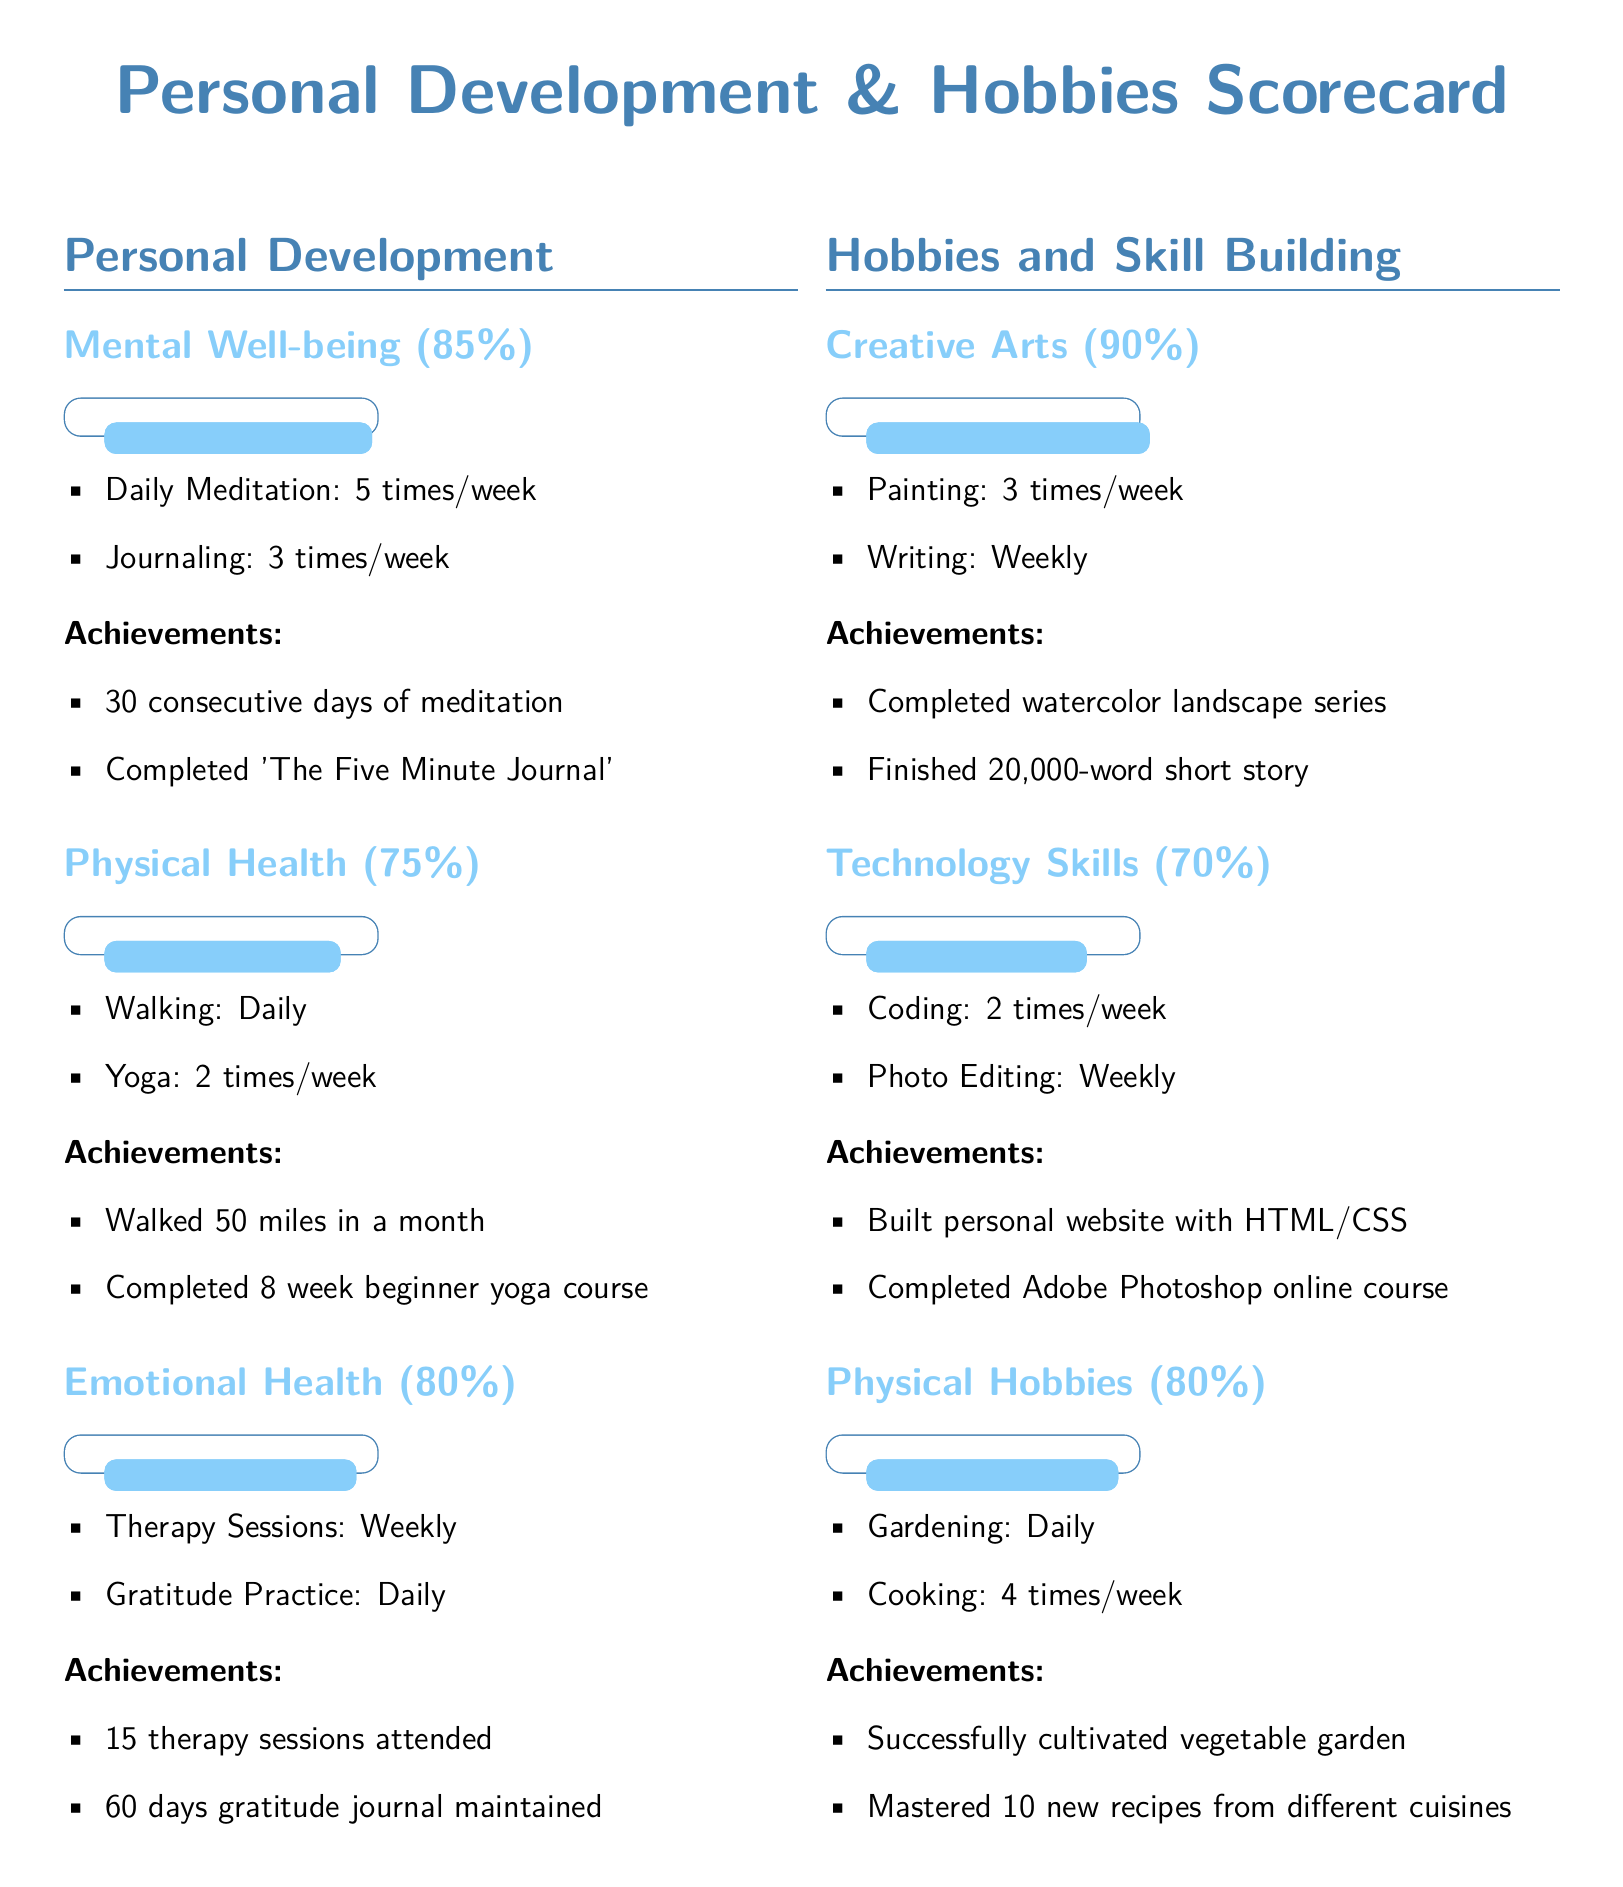What is the score for Mental Well-being? The score for Mental Well-being is provided in the document as 85%.
Answer: 85% How many times a week is painting practiced? The document states that painting is practiced 3 times a week.
Answer: 3 times/week What achievement is associated with physical hobbies? The document lists "Successfully cultivated vegetable garden" as an achievement in physical hobbies.
Answer: Successfully cultivated vegetable garden What is the percentage score for Emotional Health? The score for Emotional Health is recorded as 80%.
Answer: 80% Which skill has the lowest percentage score? The document indicates that Technology Skills has the lowest score of 70%.
Answer: Technology Skills How many therapy sessions were attended? The number of therapy sessions attended is reported as 15.
Answer: 15 What is mentioned as a daily practice for Emotional Health? The document specifies "Gratitude Practice" as a daily practice in Emotional Health.
Answer: Gratitude Practice What is the achievement in Creative Arts related to writing? The achievement related to writing in Creative Arts is "Finished 20,000-word short story."
Answer: Finished 20,000-word short story What activity is done daily in physical health? The document mentions "Walking" as an activity done daily in physical health.
Answer: Walking 